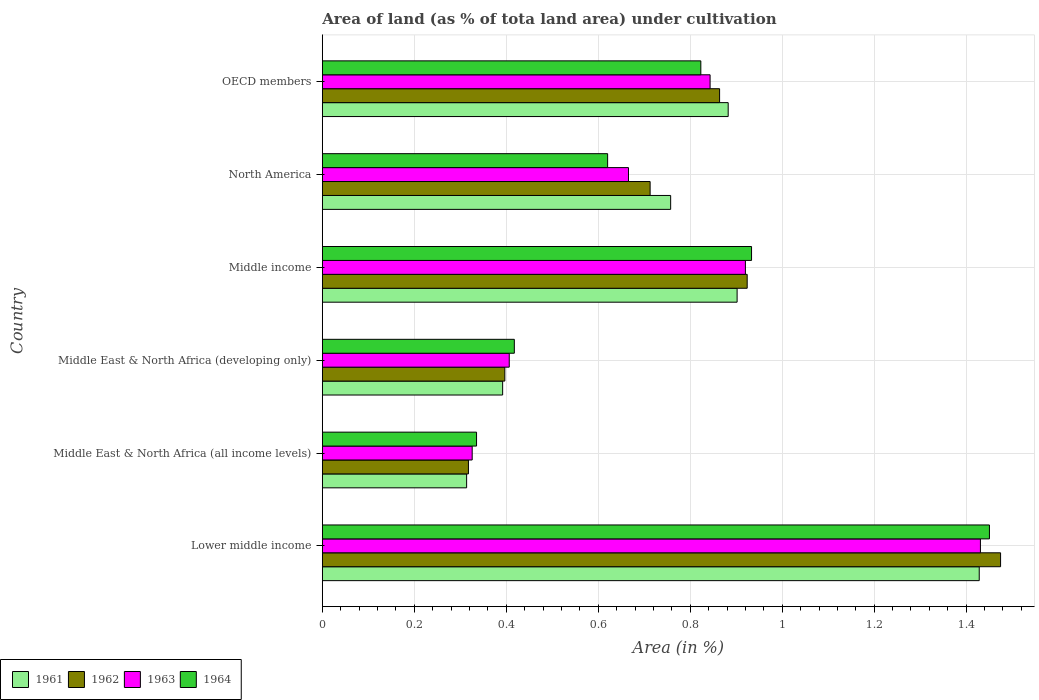How many different coloured bars are there?
Your response must be concise. 4. Are the number of bars on each tick of the Y-axis equal?
Your answer should be compact. Yes. What is the label of the 6th group of bars from the top?
Offer a terse response. Lower middle income. In how many cases, is the number of bars for a given country not equal to the number of legend labels?
Offer a terse response. 0. What is the percentage of land under cultivation in 1964 in OECD members?
Keep it short and to the point. 0.82. Across all countries, what is the maximum percentage of land under cultivation in 1964?
Your answer should be very brief. 1.45. Across all countries, what is the minimum percentage of land under cultivation in 1963?
Your answer should be very brief. 0.33. In which country was the percentage of land under cultivation in 1961 maximum?
Your answer should be compact. Lower middle income. In which country was the percentage of land under cultivation in 1963 minimum?
Give a very brief answer. Middle East & North Africa (all income levels). What is the total percentage of land under cultivation in 1964 in the graph?
Ensure brevity in your answer.  4.58. What is the difference between the percentage of land under cultivation in 1963 in Lower middle income and that in Middle income?
Provide a short and direct response. 0.51. What is the difference between the percentage of land under cultivation in 1962 in Lower middle income and the percentage of land under cultivation in 1963 in Middle East & North Africa (developing only)?
Keep it short and to the point. 1.07. What is the average percentage of land under cultivation in 1964 per country?
Offer a terse response. 0.76. What is the difference between the percentage of land under cultivation in 1963 and percentage of land under cultivation in 1961 in OECD members?
Your answer should be compact. -0.04. In how many countries, is the percentage of land under cultivation in 1964 greater than 0.68 %?
Provide a short and direct response. 3. What is the ratio of the percentage of land under cultivation in 1961 in Lower middle income to that in North America?
Your response must be concise. 1.89. What is the difference between the highest and the second highest percentage of land under cultivation in 1962?
Keep it short and to the point. 0.55. What is the difference between the highest and the lowest percentage of land under cultivation in 1962?
Offer a terse response. 1.16. Is the sum of the percentage of land under cultivation in 1962 in Middle East & North Africa (all income levels) and Middle East & North Africa (developing only) greater than the maximum percentage of land under cultivation in 1963 across all countries?
Make the answer very short. No. What does the 3rd bar from the top in North America represents?
Offer a very short reply. 1962. How many bars are there?
Offer a very short reply. 24. What is the difference between two consecutive major ticks on the X-axis?
Your answer should be compact. 0.2. Where does the legend appear in the graph?
Provide a succinct answer. Bottom left. How many legend labels are there?
Your answer should be compact. 4. How are the legend labels stacked?
Your answer should be very brief. Horizontal. What is the title of the graph?
Make the answer very short. Area of land (as % of tota land area) under cultivation. What is the label or title of the X-axis?
Your answer should be very brief. Area (in %). What is the label or title of the Y-axis?
Your answer should be compact. Country. What is the Area (in %) of 1961 in Lower middle income?
Offer a terse response. 1.43. What is the Area (in %) of 1962 in Lower middle income?
Your answer should be very brief. 1.47. What is the Area (in %) of 1963 in Lower middle income?
Offer a terse response. 1.43. What is the Area (in %) of 1964 in Lower middle income?
Ensure brevity in your answer.  1.45. What is the Area (in %) in 1961 in Middle East & North Africa (all income levels)?
Offer a terse response. 0.31. What is the Area (in %) in 1962 in Middle East & North Africa (all income levels)?
Ensure brevity in your answer.  0.32. What is the Area (in %) of 1963 in Middle East & North Africa (all income levels)?
Your answer should be compact. 0.33. What is the Area (in %) in 1964 in Middle East & North Africa (all income levels)?
Your answer should be compact. 0.34. What is the Area (in %) in 1961 in Middle East & North Africa (developing only)?
Ensure brevity in your answer.  0.39. What is the Area (in %) of 1962 in Middle East & North Africa (developing only)?
Provide a short and direct response. 0.4. What is the Area (in %) in 1963 in Middle East & North Africa (developing only)?
Your answer should be very brief. 0.41. What is the Area (in %) of 1964 in Middle East & North Africa (developing only)?
Your answer should be very brief. 0.42. What is the Area (in %) of 1961 in Middle income?
Keep it short and to the point. 0.9. What is the Area (in %) in 1962 in Middle income?
Your response must be concise. 0.92. What is the Area (in %) in 1963 in Middle income?
Offer a very short reply. 0.92. What is the Area (in %) of 1964 in Middle income?
Offer a very short reply. 0.93. What is the Area (in %) of 1961 in North America?
Make the answer very short. 0.76. What is the Area (in %) in 1962 in North America?
Your answer should be very brief. 0.71. What is the Area (in %) in 1963 in North America?
Offer a very short reply. 0.67. What is the Area (in %) in 1964 in North America?
Give a very brief answer. 0.62. What is the Area (in %) in 1961 in OECD members?
Give a very brief answer. 0.88. What is the Area (in %) of 1962 in OECD members?
Provide a short and direct response. 0.86. What is the Area (in %) in 1963 in OECD members?
Ensure brevity in your answer.  0.84. What is the Area (in %) in 1964 in OECD members?
Offer a very short reply. 0.82. Across all countries, what is the maximum Area (in %) in 1961?
Keep it short and to the point. 1.43. Across all countries, what is the maximum Area (in %) of 1962?
Your response must be concise. 1.47. Across all countries, what is the maximum Area (in %) in 1963?
Offer a very short reply. 1.43. Across all countries, what is the maximum Area (in %) in 1964?
Your response must be concise. 1.45. Across all countries, what is the minimum Area (in %) in 1961?
Provide a short and direct response. 0.31. Across all countries, what is the minimum Area (in %) of 1962?
Give a very brief answer. 0.32. Across all countries, what is the minimum Area (in %) of 1963?
Ensure brevity in your answer.  0.33. Across all countries, what is the minimum Area (in %) of 1964?
Offer a terse response. 0.34. What is the total Area (in %) of 1961 in the graph?
Your response must be concise. 4.68. What is the total Area (in %) in 1962 in the graph?
Offer a very short reply. 4.69. What is the total Area (in %) in 1963 in the graph?
Make the answer very short. 4.59. What is the total Area (in %) in 1964 in the graph?
Give a very brief answer. 4.58. What is the difference between the Area (in %) of 1961 in Lower middle income and that in Middle East & North Africa (all income levels)?
Provide a succinct answer. 1.11. What is the difference between the Area (in %) in 1962 in Lower middle income and that in Middle East & North Africa (all income levels)?
Offer a terse response. 1.16. What is the difference between the Area (in %) of 1963 in Lower middle income and that in Middle East & North Africa (all income levels)?
Give a very brief answer. 1.11. What is the difference between the Area (in %) of 1964 in Lower middle income and that in Middle East & North Africa (all income levels)?
Your response must be concise. 1.12. What is the difference between the Area (in %) in 1961 in Lower middle income and that in Middle East & North Africa (developing only)?
Your response must be concise. 1.04. What is the difference between the Area (in %) of 1962 in Lower middle income and that in Middle East & North Africa (developing only)?
Provide a succinct answer. 1.08. What is the difference between the Area (in %) of 1963 in Lower middle income and that in Middle East & North Africa (developing only)?
Keep it short and to the point. 1.02. What is the difference between the Area (in %) in 1964 in Lower middle income and that in Middle East & North Africa (developing only)?
Make the answer very short. 1.03. What is the difference between the Area (in %) of 1961 in Lower middle income and that in Middle income?
Offer a terse response. 0.53. What is the difference between the Area (in %) of 1962 in Lower middle income and that in Middle income?
Make the answer very short. 0.55. What is the difference between the Area (in %) of 1963 in Lower middle income and that in Middle income?
Ensure brevity in your answer.  0.51. What is the difference between the Area (in %) of 1964 in Lower middle income and that in Middle income?
Your answer should be very brief. 0.52. What is the difference between the Area (in %) of 1961 in Lower middle income and that in North America?
Provide a short and direct response. 0.67. What is the difference between the Area (in %) of 1962 in Lower middle income and that in North America?
Ensure brevity in your answer.  0.76. What is the difference between the Area (in %) in 1963 in Lower middle income and that in North America?
Offer a very short reply. 0.77. What is the difference between the Area (in %) of 1964 in Lower middle income and that in North America?
Offer a very short reply. 0.83. What is the difference between the Area (in %) in 1961 in Lower middle income and that in OECD members?
Offer a terse response. 0.55. What is the difference between the Area (in %) of 1962 in Lower middle income and that in OECD members?
Keep it short and to the point. 0.61. What is the difference between the Area (in %) of 1963 in Lower middle income and that in OECD members?
Make the answer very short. 0.59. What is the difference between the Area (in %) in 1964 in Lower middle income and that in OECD members?
Provide a short and direct response. 0.63. What is the difference between the Area (in %) of 1961 in Middle East & North Africa (all income levels) and that in Middle East & North Africa (developing only)?
Provide a short and direct response. -0.08. What is the difference between the Area (in %) in 1962 in Middle East & North Africa (all income levels) and that in Middle East & North Africa (developing only)?
Offer a terse response. -0.08. What is the difference between the Area (in %) of 1963 in Middle East & North Africa (all income levels) and that in Middle East & North Africa (developing only)?
Your response must be concise. -0.08. What is the difference between the Area (in %) of 1964 in Middle East & North Africa (all income levels) and that in Middle East & North Africa (developing only)?
Offer a terse response. -0.08. What is the difference between the Area (in %) in 1961 in Middle East & North Africa (all income levels) and that in Middle income?
Offer a terse response. -0.59. What is the difference between the Area (in %) of 1962 in Middle East & North Africa (all income levels) and that in Middle income?
Keep it short and to the point. -0.61. What is the difference between the Area (in %) of 1963 in Middle East & North Africa (all income levels) and that in Middle income?
Your answer should be very brief. -0.59. What is the difference between the Area (in %) of 1964 in Middle East & North Africa (all income levels) and that in Middle income?
Your answer should be compact. -0.6. What is the difference between the Area (in %) of 1961 in Middle East & North Africa (all income levels) and that in North America?
Ensure brevity in your answer.  -0.44. What is the difference between the Area (in %) in 1962 in Middle East & North Africa (all income levels) and that in North America?
Offer a very short reply. -0.4. What is the difference between the Area (in %) of 1963 in Middle East & North Africa (all income levels) and that in North America?
Offer a terse response. -0.34. What is the difference between the Area (in %) of 1964 in Middle East & North Africa (all income levels) and that in North America?
Your response must be concise. -0.28. What is the difference between the Area (in %) in 1961 in Middle East & North Africa (all income levels) and that in OECD members?
Offer a terse response. -0.57. What is the difference between the Area (in %) in 1962 in Middle East & North Africa (all income levels) and that in OECD members?
Make the answer very short. -0.55. What is the difference between the Area (in %) in 1963 in Middle East & North Africa (all income levels) and that in OECD members?
Provide a succinct answer. -0.52. What is the difference between the Area (in %) of 1964 in Middle East & North Africa (all income levels) and that in OECD members?
Provide a short and direct response. -0.49. What is the difference between the Area (in %) of 1961 in Middle East & North Africa (developing only) and that in Middle income?
Your answer should be compact. -0.51. What is the difference between the Area (in %) in 1962 in Middle East & North Africa (developing only) and that in Middle income?
Your response must be concise. -0.53. What is the difference between the Area (in %) of 1963 in Middle East & North Africa (developing only) and that in Middle income?
Make the answer very short. -0.51. What is the difference between the Area (in %) of 1964 in Middle East & North Africa (developing only) and that in Middle income?
Ensure brevity in your answer.  -0.52. What is the difference between the Area (in %) in 1961 in Middle East & North Africa (developing only) and that in North America?
Offer a terse response. -0.37. What is the difference between the Area (in %) in 1962 in Middle East & North Africa (developing only) and that in North America?
Provide a succinct answer. -0.32. What is the difference between the Area (in %) of 1963 in Middle East & North Africa (developing only) and that in North America?
Your answer should be very brief. -0.26. What is the difference between the Area (in %) of 1964 in Middle East & North Africa (developing only) and that in North America?
Offer a very short reply. -0.2. What is the difference between the Area (in %) in 1961 in Middle East & North Africa (developing only) and that in OECD members?
Your answer should be very brief. -0.49. What is the difference between the Area (in %) of 1962 in Middle East & North Africa (developing only) and that in OECD members?
Your answer should be compact. -0.47. What is the difference between the Area (in %) in 1963 in Middle East & North Africa (developing only) and that in OECD members?
Give a very brief answer. -0.44. What is the difference between the Area (in %) of 1964 in Middle East & North Africa (developing only) and that in OECD members?
Give a very brief answer. -0.41. What is the difference between the Area (in %) of 1961 in Middle income and that in North America?
Make the answer very short. 0.14. What is the difference between the Area (in %) in 1962 in Middle income and that in North America?
Your answer should be compact. 0.21. What is the difference between the Area (in %) in 1963 in Middle income and that in North America?
Your answer should be compact. 0.25. What is the difference between the Area (in %) of 1964 in Middle income and that in North America?
Give a very brief answer. 0.31. What is the difference between the Area (in %) of 1961 in Middle income and that in OECD members?
Provide a succinct answer. 0.02. What is the difference between the Area (in %) of 1963 in Middle income and that in OECD members?
Your response must be concise. 0.08. What is the difference between the Area (in %) in 1964 in Middle income and that in OECD members?
Provide a short and direct response. 0.11. What is the difference between the Area (in %) of 1961 in North America and that in OECD members?
Your answer should be very brief. -0.13. What is the difference between the Area (in %) of 1962 in North America and that in OECD members?
Give a very brief answer. -0.15. What is the difference between the Area (in %) of 1963 in North America and that in OECD members?
Make the answer very short. -0.18. What is the difference between the Area (in %) of 1964 in North America and that in OECD members?
Offer a terse response. -0.2. What is the difference between the Area (in %) of 1961 in Lower middle income and the Area (in %) of 1962 in Middle East & North Africa (all income levels)?
Give a very brief answer. 1.11. What is the difference between the Area (in %) in 1961 in Lower middle income and the Area (in %) in 1963 in Middle East & North Africa (all income levels)?
Offer a terse response. 1.1. What is the difference between the Area (in %) in 1961 in Lower middle income and the Area (in %) in 1964 in Middle East & North Africa (all income levels)?
Offer a very short reply. 1.09. What is the difference between the Area (in %) of 1962 in Lower middle income and the Area (in %) of 1963 in Middle East & North Africa (all income levels)?
Give a very brief answer. 1.15. What is the difference between the Area (in %) of 1962 in Lower middle income and the Area (in %) of 1964 in Middle East & North Africa (all income levels)?
Your answer should be very brief. 1.14. What is the difference between the Area (in %) of 1963 in Lower middle income and the Area (in %) of 1964 in Middle East & North Africa (all income levels)?
Your answer should be very brief. 1.1. What is the difference between the Area (in %) in 1961 in Lower middle income and the Area (in %) in 1962 in Middle East & North Africa (developing only)?
Provide a succinct answer. 1.03. What is the difference between the Area (in %) in 1961 in Lower middle income and the Area (in %) in 1963 in Middle East & North Africa (developing only)?
Make the answer very short. 1.02. What is the difference between the Area (in %) of 1961 in Lower middle income and the Area (in %) of 1964 in Middle East & North Africa (developing only)?
Provide a short and direct response. 1.01. What is the difference between the Area (in %) of 1962 in Lower middle income and the Area (in %) of 1963 in Middle East & North Africa (developing only)?
Make the answer very short. 1.07. What is the difference between the Area (in %) of 1962 in Lower middle income and the Area (in %) of 1964 in Middle East & North Africa (developing only)?
Your response must be concise. 1.06. What is the difference between the Area (in %) in 1963 in Lower middle income and the Area (in %) in 1964 in Middle East & North Africa (developing only)?
Keep it short and to the point. 1.01. What is the difference between the Area (in %) in 1961 in Lower middle income and the Area (in %) in 1962 in Middle income?
Your answer should be very brief. 0.5. What is the difference between the Area (in %) in 1961 in Lower middle income and the Area (in %) in 1963 in Middle income?
Give a very brief answer. 0.51. What is the difference between the Area (in %) of 1961 in Lower middle income and the Area (in %) of 1964 in Middle income?
Your response must be concise. 0.5. What is the difference between the Area (in %) of 1962 in Lower middle income and the Area (in %) of 1963 in Middle income?
Give a very brief answer. 0.55. What is the difference between the Area (in %) in 1962 in Lower middle income and the Area (in %) in 1964 in Middle income?
Make the answer very short. 0.54. What is the difference between the Area (in %) of 1963 in Lower middle income and the Area (in %) of 1964 in Middle income?
Offer a terse response. 0.5. What is the difference between the Area (in %) in 1961 in Lower middle income and the Area (in %) in 1962 in North America?
Offer a terse response. 0.72. What is the difference between the Area (in %) of 1961 in Lower middle income and the Area (in %) of 1963 in North America?
Give a very brief answer. 0.76. What is the difference between the Area (in %) of 1961 in Lower middle income and the Area (in %) of 1964 in North America?
Your answer should be very brief. 0.81. What is the difference between the Area (in %) of 1962 in Lower middle income and the Area (in %) of 1963 in North America?
Provide a succinct answer. 0.81. What is the difference between the Area (in %) in 1962 in Lower middle income and the Area (in %) in 1964 in North America?
Ensure brevity in your answer.  0.85. What is the difference between the Area (in %) in 1963 in Lower middle income and the Area (in %) in 1964 in North America?
Provide a short and direct response. 0.81. What is the difference between the Area (in %) in 1961 in Lower middle income and the Area (in %) in 1962 in OECD members?
Offer a very short reply. 0.56. What is the difference between the Area (in %) of 1961 in Lower middle income and the Area (in %) of 1963 in OECD members?
Your answer should be compact. 0.59. What is the difference between the Area (in %) of 1961 in Lower middle income and the Area (in %) of 1964 in OECD members?
Your answer should be compact. 0.61. What is the difference between the Area (in %) of 1962 in Lower middle income and the Area (in %) of 1963 in OECD members?
Provide a succinct answer. 0.63. What is the difference between the Area (in %) of 1962 in Lower middle income and the Area (in %) of 1964 in OECD members?
Provide a short and direct response. 0.65. What is the difference between the Area (in %) of 1963 in Lower middle income and the Area (in %) of 1964 in OECD members?
Offer a terse response. 0.61. What is the difference between the Area (in %) in 1961 in Middle East & North Africa (all income levels) and the Area (in %) in 1962 in Middle East & North Africa (developing only)?
Your answer should be compact. -0.08. What is the difference between the Area (in %) of 1961 in Middle East & North Africa (all income levels) and the Area (in %) of 1963 in Middle East & North Africa (developing only)?
Keep it short and to the point. -0.09. What is the difference between the Area (in %) in 1961 in Middle East & North Africa (all income levels) and the Area (in %) in 1964 in Middle East & North Africa (developing only)?
Ensure brevity in your answer.  -0.1. What is the difference between the Area (in %) of 1962 in Middle East & North Africa (all income levels) and the Area (in %) of 1963 in Middle East & North Africa (developing only)?
Your answer should be compact. -0.09. What is the difference between the Area (in %) in 1962 in Middle East & North Africa (all income levels) and the Area (in %) in 1964 in Middle East & North Africa (developing only)?
Ensure brevity in your answer.  -0.1. What is the difference between the Area (in %) in 1963 in Middle East & North Africa (all income levels) and the Area (in %) in 1964 in Middle East & North Africa (developing only)?
Offer a very short reply. -0.09. What is the difference between the Area (in %) in 1961 in Middle East & North Africa (all income levels) and the Area (in %) in 1962 in Middle income?
Give a very brief answer. -0.61. What is the difference between the Area (in %) in 1961 in Middle East & North Africa (all income levels) and the Area (in %) in 1963 in Middle income?
Your answer should be very brief. -0.61. What is the difference between the Area (in %) of 1961 in Middle East & North Africa (all income levels) and the Area (in %) of 1964 in Middle income?
Provide a short and direct response. -0.62. What is the difference between the Area (in %) of 1962 in Middle East & North Africa (all income levels) and the Area (in %) of 1963 in Middle income?
Offer a terse response. -0.6. What is the difference between the Area (in %) of 1962 in Middle East & North Africa (all income levels) and the Area (in %) of 1964 in Middle income?
Offer a very short reply. -0.62. What is the difference between the Area (in %) of 1963 in Middle East & North Africa (all income levels) and the Area (in %) of 1964 in Middle income?
Your answer should be very brief. -0.61. What is the difference between the Area (in %) of 1961 in Middle East & North Africa (all income levels) and the Area (in %) of 1962 in North America?
Offer a terse response. -0.4. What is the difference between the Area (in %) in 1961 in Middle East & North Africa (all income levels) and the Area (in %) in 1963 in North America?
Keep it short and to the point. -0.35. What is the difference between the Area (in %) in 1961 in Middle East & North Africa (all income levels) and the Area (in %) in 1964 in North America?
Offer a very short reply. -0.31. What is the difference between the Area (in %) in 1962 in Middle East & North Africa (all income levels) and the Area (in %) in 1963 in North America?
Offer a very short reply. -0.35. What is the difference between the Area (in %) in 1962 in Middle East & North Africa (all income levels) and the Area (in %) in 1964 in North America?
Give a very brief answer. -0.3. What is the difference between the Area (in %) of 1963 in Middle East & North Africa (all income levels) and the Area (in %) of 1964 in North America?
Offer a terse response. -0.29. What is the difference between the Area (in %) of 1961 in Middle East & North Africa (all income levels) and the Area (in %) of 1962 in OECD members?
Offer a very short reply. -0.55. What is the difference between the Area (in %) of 1961 in Middle East & North Africa (all income levels) and the Area (in %) of 1963 in OECD members?
Keep it short and to the point. -0.53. What is the difference between the Area (in %) in 1961 in Middle East & North Africa (all income levels) and the Area (in %) in 1964 in OECD members?
Provide a succinct answer. -0.51. What is the difference between the Area (in %) in 1962 in Middle East & North Africa (all income levels) and the Area (in %) in 1963 in OECD members?
Make the answer very short. -0.53. What is the difference between the Area (in %) of 1962 in Middle East & North Africa (all income levels) and the Area (in %) of 1964 in OECD members?
Offer a very short reply. -0.51. What is the difference between the Area (in %) in 1963 in Middle East & North Africa (all income levels) and the Area (in %) in 1964 in OECD members?
Provide a short and direct response. -0.5. What is the difference between the Area (in %) of 1961 in Middle East & North Africa (developing only) and the Area (in %) of 1962 in Middle income?
Offer a terse response. -0.53. What is the difference between the Area (in %) of 1961 in Middle East & North Africa (developing only) and the Area (in %) of 1963 in Middle income?
Provide a short and direct response. -0.53. What is the difference between the Area (in %) in 1961 in Middle East & North Africa (developing only) and the Area (in %) in 1964 in Middle income?
Provide a short and direct response. -0.54. What is the difference between the Area (in %) of 1962 in Middle East & North Africa (developing only) and the Area (in %) of 1963 in Middle income?
Ensure brevity in your answer.  -0.52. What is the difference between the Area (in %) of 1962 in Middle East & North Africa (developing only) and the Area (in %) of 1964 in Middle income?
Keep it short and to the point. -0.54. What is the difference between the Area (in %) in 1963 in Middle East & North Africa (developing only) and the Area (in %) in 1964 in Middle income?
Your response must be concise. -0.53. What is the difference between the Area (in %) of 1961 in Middle East & North Africa (developing only) and the Area (in %) of 1962 in North America?
Offer a terse response. -0.32. What is the difference between the Area (in %) in 1961 in Middle East & North Africa (developing only) and the Area (in %) in 1963 in North America?
Your response must be concise. -0.27. What is the difference between the Area (in %) of 1961 in Middle East & North Africa (developing only) and the Area (in %) of 1964 in North America?
Provide a short and direct response. -0.23. What is the difference between the Area (in %) of 1962 in Middle East & North Africa (developing only) and the Area (in %) of 1963 in North America?
Keep it short and to the point. -0.27. What is the difference between the Area (in %) of 1962 in Middle East & North Africa (developing only) and the Area (in %) of 1964 in North America?
Offer a very short reply. -0.22. What is the difference between the Area (in %) in 1963 in Middle East & North Africa (developing only) and the Area (in %) in 1964 in North America?
Provide a short and direct response. -0.21. What is the difference between the Area (in %) in 1961 in Middle East & North Africa (developing only) and the Area (in %) in 1962 in OECD members?
Ensure brevity in your answer.  -0.47. What is the difference between the Area (in %) of 1961 in Middle East & North Africa (developing only) and the Area (in %) of 1963 in OECD members?
Provide a short and direct response. -0.45. What is the difference between the Area (in %) in 1961 in Middle East & North Africa (developing only) and the Area (in %) in 1964 in OECD members?
Your answer should be compact. -0.43. What is the difference between the Area (in %) of 1962 in Middle East & North Africa (developing only) and the Area (in %) of 1963 in OECD members?
Make the answer very short. -0.45. What is the difference between the Area (in %) of 1962 in Middle East & North Africa (developing only) and the Area (in %) of 1964 in OECD members?
Give a very brief answer. -0.43. What is the difference between the Area (in %) of 1963 in Middle East & North Africa (developing only) and the Area (in %) of 1964 in OECD members?
Provide a short and direct response. -0.42. What is the difference between the Area (in %) of 1961 in Middle income and the Area (in %) of 1962 in North America?
Make the answer very short. 0.19. What is the difference between the Area (in %) of 1961 in Middle income and the Area (in %) of 1963 in North America?
Provide a short and direct response. 0.24. What is the difference between the Area (in %) in 1961 in Middle income and the Area (in %) in 1964 in North America?
Offer a very short reply. 0.28. What is the difference between the Area (in %) of 1962 in Middle income and the Area (in %) of 1963 in North America?
Give a very brief answer. 0.26. What is the difference between the Area (in %) of 1962 in Middle income and the Area (in %) of 1964 in North America?
Offer a very short reply. 0.3. What is the difference between the Area (in %) in 1963 in Middle income and the Area (in %) in 1964 in North America?
Your response must be concise. 0.3. What is the difference between the Area (in %) in 1961 in Middle income and the Area (in %) in 1962 in OECD members?
Keep it short and to the point. 0.04. What is the difference between the Area (in %) of 1961 in Middle income and the Area (in %) of 1963 in OECD members?
Offer a very short reply. 0.06. What is the difference between the Area (in %) of 1961 in Middle income and the Area (in %) of 1964 in OECD members?
Your response must be concise. 0.08. What is the difference between the Area (in %) of 1962 in Middle income and the Area (in %) of 1963 in OECD members?
Your answer should be compact. 0.08. What is the difference between the Area (in %) in 1962 in Middle income and the Area (in %) in 1964 in OECD members?
Your answer should be compact. 0.1. What is the difference between the Area (in %) of 1963 in Middle income and the Area (in %) of 1964 in OECD members?
Offer a terse response. 0.1. What is the difference between the Area (in %) of 1961 in North America and the Area (in %) of 1962 in OECD members?
Provide a succinct answer. -0.11. What is the difference between the Area (in %) in 1961 in North America and the Area (in %) in 1963 in OECD members?
Your answer should be compact. -0.09. What is the difference between the Area (in %) of 1961 in North America and the Area (in %) of 1964 in OECD members?
Your answer should be compact. -0.07. What is the difference between the Area (in %) of 1962 in North America and the Area (in %) of 1963 in OECD members?
Give a very brief answer. -0.13. What is the difference between the Area (in %) in 1962 in North America and the Area (in %) in 1964 in OECD members?
Keep it short and to the point. -0.11. What is the difference between the Area (in %) in 1963 in North America and the Area (in %) in 1964 in OECD members?
Offer a terse response. -0.16. What is the average Area (in %) in 1961 per country?
Make the answer very short. 0.78. What is the average Area (in %) of 1962 per country?
Give a very brief answer. 0.78. What is the average Area (in %) in 1963 per country?
Make the answer very short. 0.77. What is the average Area (in %) in 1964 per country?
Ensure brevity in your answer.  0.76. What is the difference between the Area (in %) in 1961 and Area (in %) in 1962 in Lower middle income?
Provide a short and direct response. -0.05. What is the difference between the Area (in %) of 1961 and Area (in %) of 1963 in Lower middle income?
Provide a short and direct response. -0. What is the difference between the Area (in %) in 1961 and Area (in %) in 1964 in Lower middle income?
Ensure brevity in your answer.  -0.02. What is the difference between the Area (in %) in 1962 and Area (in %) in 1963 in Lower middle income?
Give a very brief answer. 0.04. What is the difference between the Area (in %) in 1962 and Area (in %) in 1964 in Lower middle income?
Offer a terse response. 0.02. What is the difference between the Area (in %) of 1963 and Area (in %) of 1964 in Lower middle income?
Provide a succinct answer. -0.02. What is the difference between the Area (in %) of 1961 and Area (in %) of 1962 in Middle East & North Africa (all income levels)?
Your response must be concise. -0. What is the difference between the Area (in %) in 1961 and Area (in %) in 1963 in Middle East & North Africa (all income levels)?
Your answer should be very brief. -0.01. What is the difference between the Area (in %) of 1961 and Area (in %) of 1964 in Middle East & North Africa (all income levels)?
Make the answer very short. -0.02. What is the difference between the Area (in %) in 1962 and Area (in %) in 1963 in Middle East & North Africa (all income levels)?
Offer a terse response. -0.01. What is the difference between the Area (in %) of 1962 and Area (in %) of 1964 in Middle East & North Africa (all income levels)?
Offer a very short reply. -0.02. What is the difference between the Area (in %) in 1963 and Area (in %) in 1964 in Middle East & North Africa (all income levels)?
Your response must be concise. -0.01. What is the difference between the Area (in %) in 1961 and Area (in %) in 1962 in Middle East & North Africa (developing only)?
Make the answer very short. -0. What is the difference between the Area (in %) in 1961 and Area (in %) in 1963 in Middle East & North Africa (developing only)?
Offer a very short reply. -0.01. What is the difference between the Area (in %) of 1961 and Area (in %) of 1964 in Middle East & North Africa (developing only)?
Provide a short and direct response. -0.03. What is the difference between the Area (in %) of 1962 and Area (in %) of 1963 in Middle East & North Africa (developing only)?
Offer a terse response. -0.01. What is the difference between the Area (in %) of 1962 and Area (in %) of 1964 in Middle East & North Africa (developing only)?
Your response must be concise. -0.02. What is the difference between the Area (in %) of 1963 and Area (in %) of 1964 in Middle East & North Africa (developing only)?
Ensure brevity in your answer.  -0.01. What is the difference between the Area (in %) in 1961 and Area (in %) in 1962 in Middle income?
Keep it short and to the point. -0.02. What is the difference between the Area (in %) of 1961 and Area (in %) of 1963 in Middle income?
Keep it short and to the point. -0.02. What is the difference between the Area (in %) in 1961 and Area (in %) in 1964 in Middle income?
Make the answer very short. -0.03. What is the difference between the Area (in %) of 1962 and Area (in %) of 1963 in Middle income?
Your response must be concise. 0. What is the difference between the Area (in %) of 1962 and Area (in %) of 1964 in Middle income?
Make the answer very short. -0.01. What is the difference between the Area (in %) of 1963 and Area (in %) of 1964 in Middle income?
Your answer should be very brief. -0.01. What is the difference between the Area (in %) of 1961 and Area (in %) of 1962 in North America?
Provide a succinct answer. 0.04. What is the difference between the Area (in %) of 1961 and Area (in %) of 1963 in North America?
Your response must be concise. 0.09. What is the difference between the Area (in %) in 1961 and Area (in %) in 1964 in North America?
Keep it short and to the point. 0.14. What is the difference between the Area (in %) in 1962 and Area (in %) in 1963 in North America?
Make the answer very short. 0.05. What is the difference between the Area (in %) in 1962 and Area (in %) in 1964 in North America?
Give a very brief answer. 0.09. What is the difference between the Area (in %) in 1963 and Area (in %) in 1964 in North America?
Your answer should be compact. 0.05. What is the difference between the Area (in %) in 1961 and Area (in %) in 1962 in OECD members?
Your answer should be compact. 0.02. What is the difference between the Area (in %) in 1961 and Area (in %) in 1963 in OECD members?
Give a very brief answer. 0.04. What is the difference between the Area (in %) of 1961 and Area (in %) of 1964 in OECD members?
Provide a succinct answer. 0.06. What is the difference between the Area (in %) of 1962 and Area (in %) of 1963 in OECD members?
Your response must be concise. 0.02. What is the difference between the Area (in %) in 1962 and Area (in %) in 1964 in OECD members?
Your answer should be compact. 0.04. What is the difference between the Area (in %) of 1963 and Area (in %) of 1964 in OECD members?
Provide a succinct answer. 0.02. What is the ratio of the Area (in %) in 1961 in Lower middle income to that in Middle East & North Africa (all income levels)?
Your response must be concise. 4.55. What is the ratio of the Area (in %) in 1962 in Lower middle income to that in Middle East & North Africa (all income levels)?
Offer a terse response. 4.64. What is the ratio of the Area (in %) of 1963 in Lower middle income to that in Middle East & North Africa (all income levels)?
Give a very brief answer. 4.39. What is the ratio of the Area (in %) in 1964 in Lower middle income to that in Middle East & North Africa (all income levels)?
Offer a terse response. 4.33. What is the ratio of the Area (in %) in 1961 in Lower middle income to that in Middle East & North Africa (developing only)?
Make the answer very short. 3.64. What is the ratio of the Area (in %) in 1962 in Lower middle income to that in Middle East & North Africa (developing only)?
Give a very brief answer. 3.72. What is the ratio of the Area (in %) in 1963 in Lower middle income to that in Middle East & North Africa (developing only)?
Your answer should be very brief. 3.52. What is the ratio of the Area (in %) of 1964 in Lower middle income to that in Middle East & North Africa (developing only)?
Give a very brief answer. 3.47. What is the ratio of the Area (in %) of 1961 in Lower middle income to that in Middle income?
Give a very brief answer. 1.58. What is the ratio of the Area (in %) in 1962 in Lower middle income to that in Middle income?
Your answer should be compact. 1.6. What is the ratio of the Area (in %) of 1963 in Lower middle income to that in Middle income?
Ensure brevity in your answer.  1.56. What is the ratio of the Area (in %) in 1964 in Lower middle income to that in Middle income?
Provide a succinct answer. 1.55. What is the ratio of the Area (in %) of 1961 in Lower middle income to that in North America?
Your answer should be very brief. 1.89. What is the ratio of the Area (in %) of 1962 in Lower middle income to that in North America?
Offer a terse response. 2.07. What is the ratio of the Area (in %) in 1963 in Lower middle income to that in North America?
Ensure brevity in your answer.  2.15. What is the ratio of the Area (in %) in 1964 in Lower middle income to that in North America?
Make the answer very short. 2.34. What is the ratio of the Area (in %) in 1961 in Lower middle income to that in OECD members?
Your answer should be compact. 1.62. What is the ratio of the Area (in %) of 1962 in Lower middle income to that in OECD members?
Provide a succinct answer. 1.71. What is the ratio of the Area (in %) of 1963 in Lower middle income to that in OECD members?
Your response must be concise. 1.7. What is the ratio of the Area (in %) of 1964 in Lower middle income to that in OECD members?
Offer a very short reply. 1.76. What is the ratio of the Area (in %) of 1961 in Middle East & North Africa (all income levels) to that in Middle East & North Africa (developing only)?
Offer a terse response. 0.8. What is the ratio of the Area (in %) of 1962 in Middle East & North Africa (all income levels) to that in Middle East & North Africa (developing only)?
Ensure brevity in your answer.  0.8. What is the ratio of the Area (in %) in 1963 in Middle East & North Africa (all income levels) to that in Middle East & North Africa (developing only)?
Offer a very short reply. 0.8. What is the ratio of the Area (in %) of 1964 in Middle East & North Africa (all income levels) to that in Middle East & North Africa (developing only)?
Provide a succinct answer. 0.8. What is the ratio of the Area (in %) of 1961 in Middle East & North Africa (all income levels) to that in Middle income?
Provide a succinct answer. 0.35. What is the ratio of the Area (in %) in 1962 in Middle East & North Africa (all income levels) to that in Middle income?
Offer a very short reply. 0.34. What is the ratio of the Area (in %) of 1963 in Middle East & North Africa (all income levels) to that in Middle income?
Your answer should be compact. 0.35. What is the ratio of the Area (in %) in 1964 in Middle East & North Africa (all income levels) to that in Middle income?
Your answer should be compact. 0.36. What is the ratio of the Area (in %) of 1961 in Middle East & North Africa (all income levels) to that in North America?
Offer a very short reply. 0.41. What is the ratio of the Area (in %) in 1962 in Middle East & North Africa (all income levels) to that in North America?
Provide a succinct answer. 0.45. What is the ratio of the Area (in %) of 1963 in Middle East & North Africa (all income levels) to that in North America?
Make the answer very short. 0.49. What is the ratio of the Area (in %) in 1964 in Middle East & North Africa (all income levels) to that in North America?
Keep it short and to the point. 0.54. What is the ratio of the Area (in %) of 1961 in Middle East & North Africa (all income levels) to that in OECD members?
Provide a short and direct response. 0.36. What is the ratio of the Area (in %) of 1962 in Middle East & North Africa (all income levels) to that in OECD members?
Make the answer very short. 0.37. What is the ratio of the Area (in %) of 1963 in Middle East & North Africa (all income levels) to that in OECD members?
Keep it short and to the point. 0.39. What is the ratio of the Area (in %) of 1964 in Middle East & North Africa (all income levels) to that in OECD members?
Ensure brevity in your answer.  0.41. What is the ratio of the Area (in %) in 1961 in Middle East & North Africa (developing only) to that in Middle income?
Your answer should be compact. 0.43. What is the ratio of the Area (in %) in 1962 in Middle East & North Africa (developing only) to that in Middle income?
Provide a short and direct response. 0.43. What is the ratio of the Area (in %) in 1963 in Middle East & North Africa (developing only) to that in Middle income?
Your answer should be very brief. 0.44. What is the ratio of the Area (in %) in 1964 in Middle East & North Africa (developing only) to that in Middle income?
Make the answer very short. 0.45. What is the ratio of the Area (in %) of 1961 in Middle East & North Africa (developing only) to that in North America?
Your response must be concise. 0.52. What is the ratio of the Area (in %) of 1962 in Middle East & North Africa (developing only) to that in North America?
Keep it short and to the point. 0.56. What is the ratio of the Area (in %) in 1963 in Middle East & North Africa (developing only) to that in North America?
Offer a very short reply. 0.61. What is the ratio of the Area (in %) in 1964 in Middle East & North Africa (developing only) to that in North America?
Provide a short and direct response. 0.67. What is the ratio of the Area (in %) of 1961 in Middle East & North Africa (developing only) to that in OECD members?
Make the answer very short. 0.44. What is the ratio of the Area (in %) of 1962 in Middle East & North Africa (developing only) to that in OECD members?
Provide a succinct answer. 0.46. What is the ratio of the Area (in %) of 1963 in Middle East & North Africa (developing only) to that in OECD members?
Provide a succinct answer. 0.48. What is the ratio of the Area (in %) of 1964 in Middle East & North Africa (developing only) to that in OECD members?
Your answer should be compact. 0.51. What is the ratio of the Area (in %) of 1961 in Middle income to that in North America?
Your answer should be compact. 1.19. What is the ratio of the Area (in %) of 1962 in Middle income to that in North America?
Make the answer very short. 1.3. What is the ratio of the Area (in %) in 1963 in Middle income to that in North America?
Offer a terse response. 1.38. What is the ratio of the Area (in %) in 1964 in Middle income to that in North America?
Your answer should be very brief. 1.5. What is the ratio of the Area (in %) of 1961 in Middle income to that in OECD members?
Provide a succinct answer. 1.02. What is the ratio of the Area (in %) in 1962 in Middle income to that in OECD members?
Ensure brevity in your answer.  1.07. What is the ratio of the Area (in %) in 1963 in Middle income to that in OECD members?
Provide a succinct answer. 1.09. What is the ratio of the Area (in %) in 1964 in Middle income to that in OECD members?
Offer a terse response. 1.13. What is the ratio of the Area (in %) of 1961 in North America to that in OECD members?
Offer a terse response. 0.86. What is the ratio of the Area (in %) in 1962 in North America to that in OECD members?
Your answer should be very brief. 0.83. What is the ratio of the Area (in %) in 1963 in North America to that in OECD members?
Give a very brief answer. 0.79. What is the ratio of the Area (in %) in 1964 in North America to that in OECD members?
Your answer should be compact. 0.75. What is the difference between the highest and the second highest Area (in %) in 1961?
Your response must be concise. 0.53. What is the difference between the highest and the second highest Area (in %) of 1962?
Offer a terse response. 0.55. What is the difference between the highest and the second highest Area (in %) in 1963?
Your answer should be very brief. 0.51. What is the difference between the highest and the second highest Area (in %) in 1964?
Make the answer very short. 0.52. What is the difference between the highest and the lowest Area (in %) in 1961?
Offer a terse response. 1.11. What is the difference between the highest and the lowest Area (in %) of 1962?
Make the answer very short. 1.16. What is the difference between the highest and the lowest Area (in %) in 1963?
Give a very brief answer. 1.11. What is the difference between the highest and the lowest Area (in %) in 1964?
Offer a terse response. 1.12. 